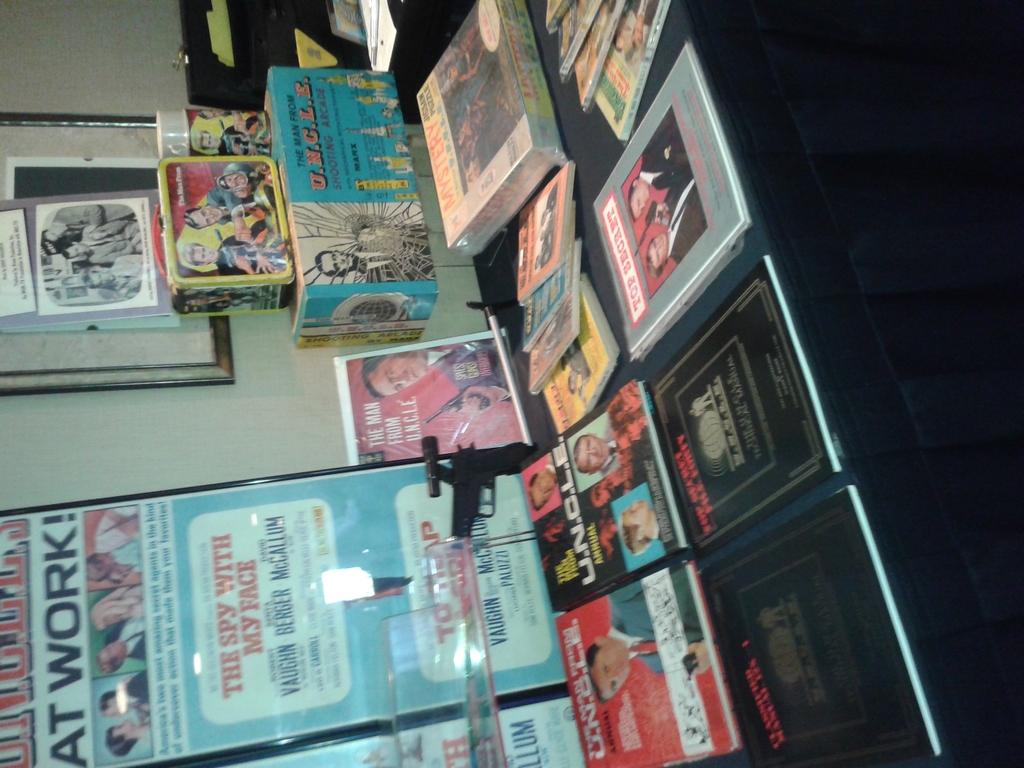<image>
Present a compact description of the photo's key features. A book called U.N.C.L.E sits among a display of books on a table 